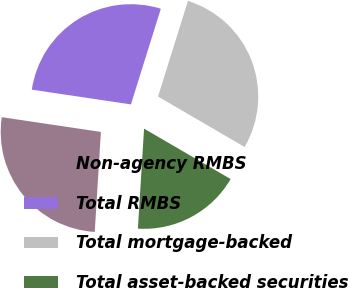<chart> <loc_0><loc_0><loc_500><loc_500><pie_chart><fcel>Non-agency RMBS<fcel>Total RMBS<fcel>Total mortgage-backed<fcel>Total asset-backed securities<nl><fcel>26.37%<fcel>27.47%<fcel>28.57%<fcel>17.58%<nl></chart> 